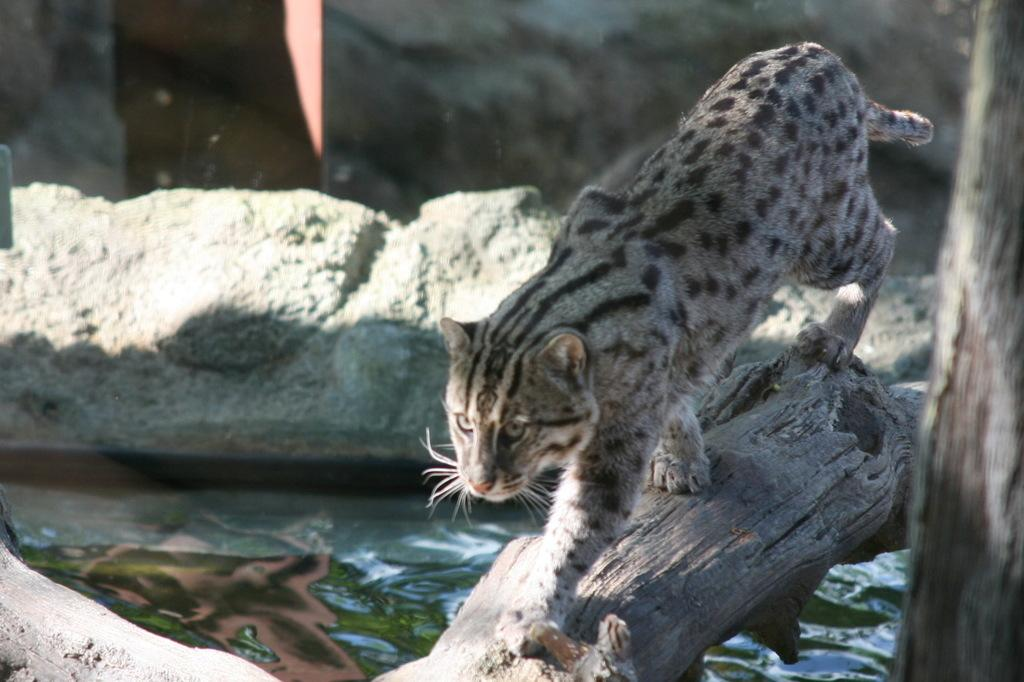What is on the trunk of the tree in the image? There is an animal on the trunk of a tree in the image. What can be seen in the image besides the tree and animal? There is water, the ground, a background, and an object on the right side of the image. Can you describe the water in the image? The water is visible in the image, but its specific characteristics are not mentioned in the facts. What is the object on the right side of the image? The facts do not specify what the object is, only that it is on the right side of the image. What type of lock can be seen securing the bone in the image? There is no lock or bone present in the image; it features an animal on a tree trunk and other elements mentioned in the conversation. 